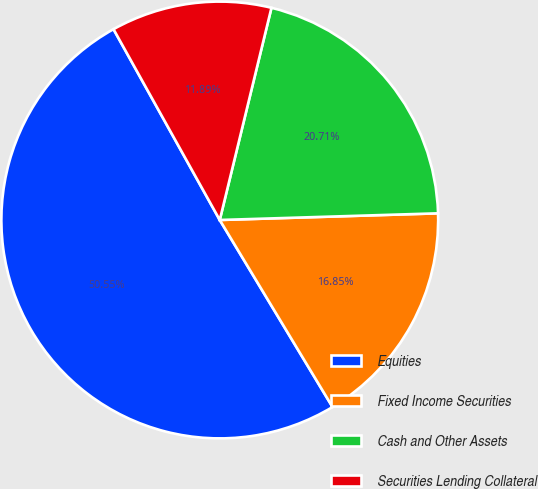Convert chart to OTSL. <chart><loc_0><loc_0><loc_500><loc_500><pie_chart><fcel>Equities<fcel>Fixed Income Securities<fcel>Cash and Other Assets<fcel>Securities Lending Collateral<nl><fcel>50.55%<fcel>16.85%<fcel>20.71%<fcel>11.89%<nl></chart> 